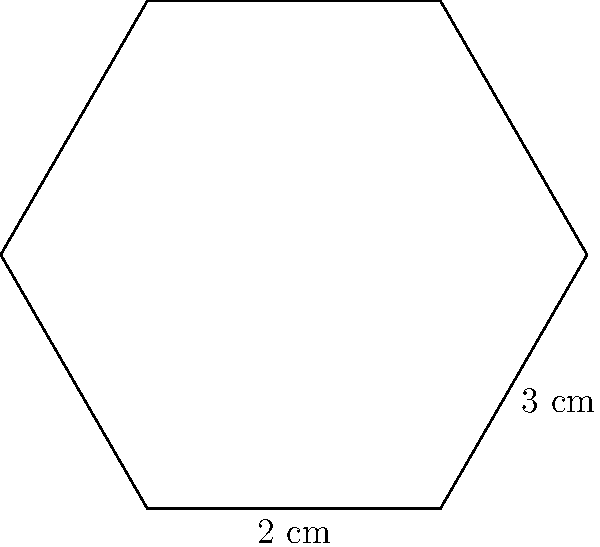You've crafted a delightful hexagonal soap bar with a light, fresh scent for your blog review. The soap has a side length of 2 cm and a height of 3 cm, as shown in the diagram. What is the perimeter of this aromatic creation? To find the perimeter of the hexagonal soap bar, we need to follow these steps:

1. Identify the shape: The soap bar is a regular hexagon.

2. Recall the formula for the perimeter of a regular hexagon:
   Perimeter = 6 * side length

3. We're given that the side length is 2 cm.

4. Apply the formula:
   Perimeter = 6 * 2 cm = 12 cm

Note: The height (3 cm) is not needed for this calculation, as the perimeter only depends on the side length.
Answer: 12 cm 